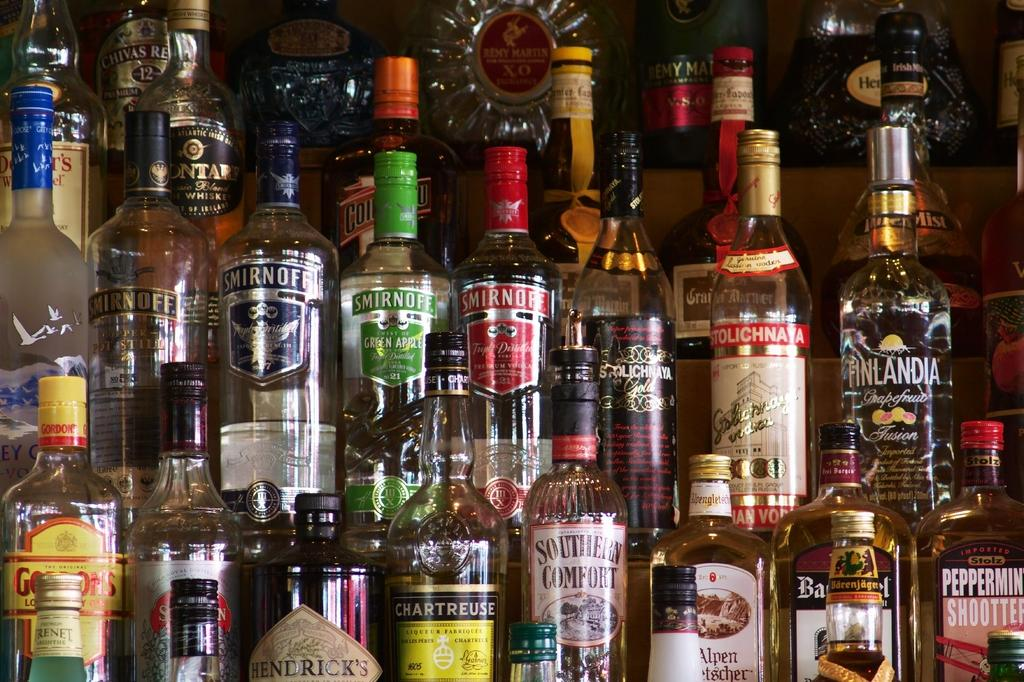Provide a one-sentence caption for the provided image. A shelf of liqour including Smirnoff and Stolichayna. 